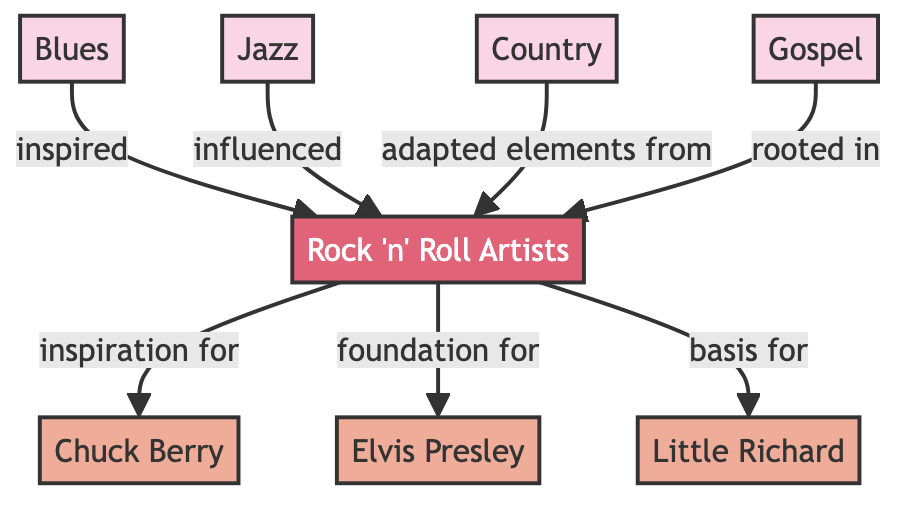What music genres are connected to Rock 'n' Roll? The diagram shows four music genres that are connected to Rock 'n' Roll: Blues, Jazz, Country, and Gospel. These genres are linked to Rock 'n' Roll as they either inspire, influence, adapt elements from, or are rooted in it.
Answer: Blues, Jazz, Country, Gospel How many Rock 'n' Roll artists are listed? The diagram lists three Rock 'n' Roll artists: Chuck Berry, Elvis Presley, and Little Richard. This can be counted directly from the nodes designated as artists within the diagram.
Answer: 3 Which genre is rooted in Rock 'n' Roll? The diagram indicates that Gospel is rooted in Rock 'n' Roll, as depicted by the directed edge from Gospel to Rock 'n' Roll with the label "rooted in."
Answer: Gospel What is the relationship between Jazz and Rock 'n' Roll? The diagram shows that Jazz influenced Rock 'n' Roll, signified by the directed connection from Jazz to Rock 'n' Roll with the label "influenced."
Answer: influenced Which artist has Rock 'n' Roll as a foundation? According to the diagram, Elvis Presley has Rock 'n' Roll as a foundation, represented by the edge pointing to Elvis Presley labeled "foundation for."
Answer: Elvis Presley How does Country relate to Rock 'n' Roll? The relationship shown in the diagram indicates that Country adapted elements from Rock 'n' Roll, demonstrated by the directed edge from Country to Rock 'n' Roll and the labeling "adapted elements from."
Answer: adapted elements from Which artist is inspired by Rock 'n' Roll? The diagram illustrates that Chuck Berry is inspired by Rock 'n' Roll, represented by the arrow pointing to Chuck Berry with the label "inspiration for."
Answer: Chuck Berry What type of diagram is this? The diagram is a flowchart representing a food chain of dependencies among music genres and Rock 'n' Roll artists. This is evident from the structure showing connections and directional arrows between different entities.
Answer: flowchart Which genre inspired Rock 'n' Roll? The diagram shows that Blues inspired Rock 'n' Roll, indicated by the directed edge from Blues to Rock 'n' Roll labeled "inspired."
Answer: Blues 